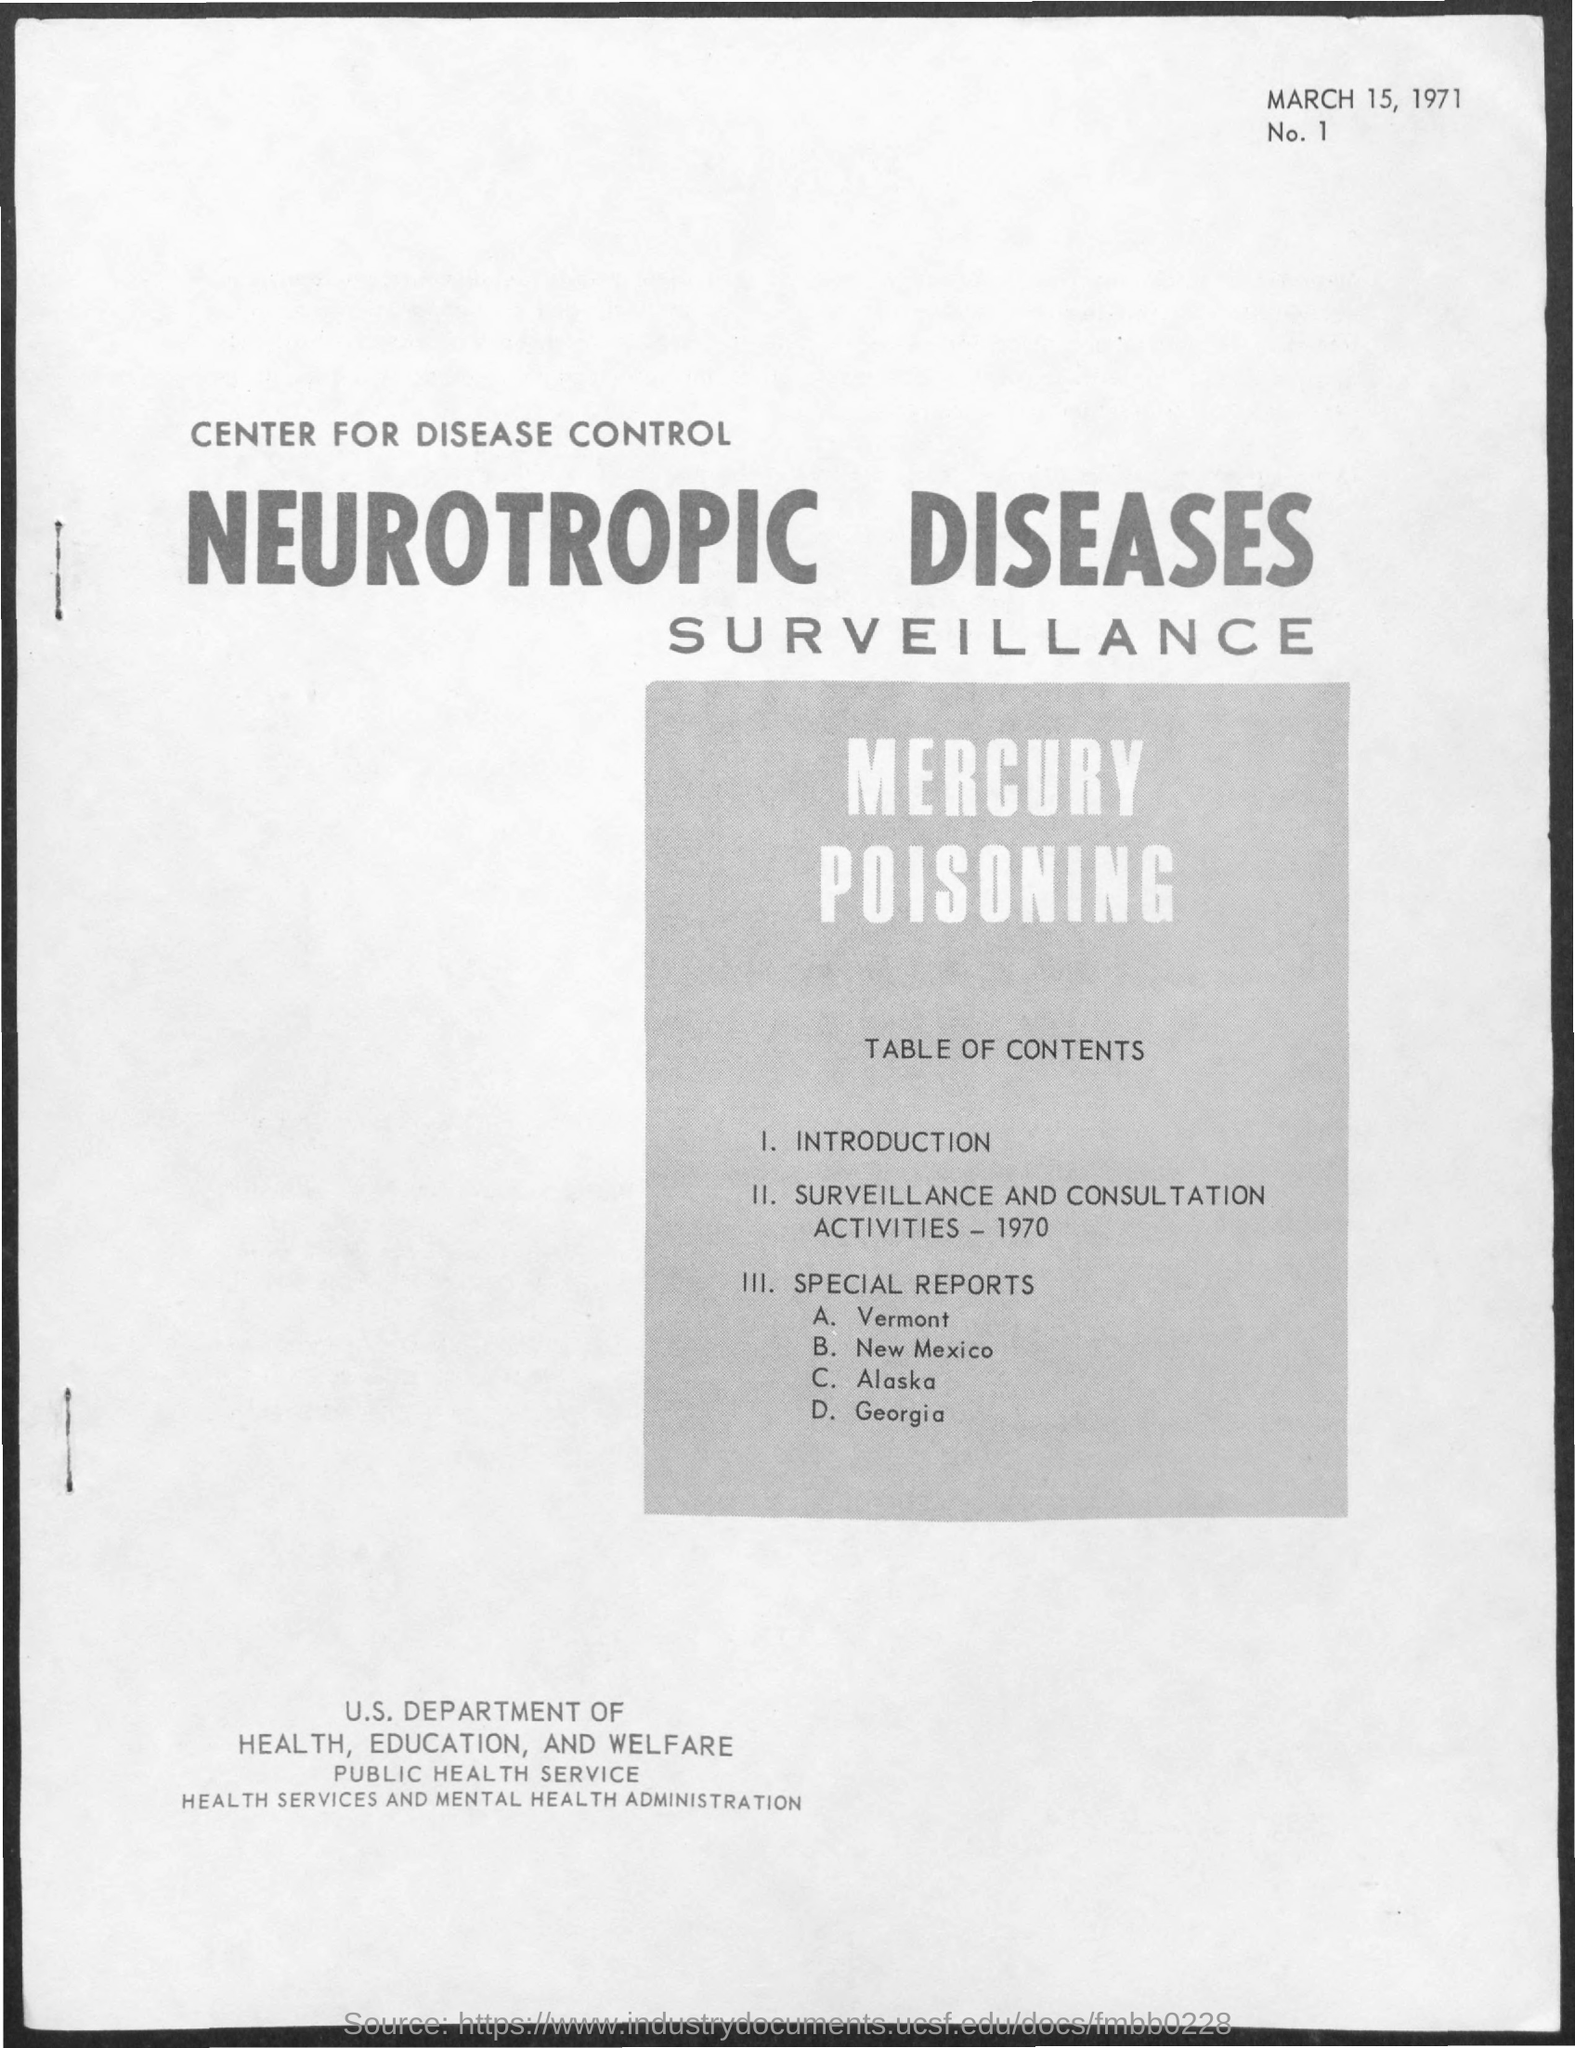What is the date mentioned in this document?
Your answer should be very brief. MARCH 15, 1971. 